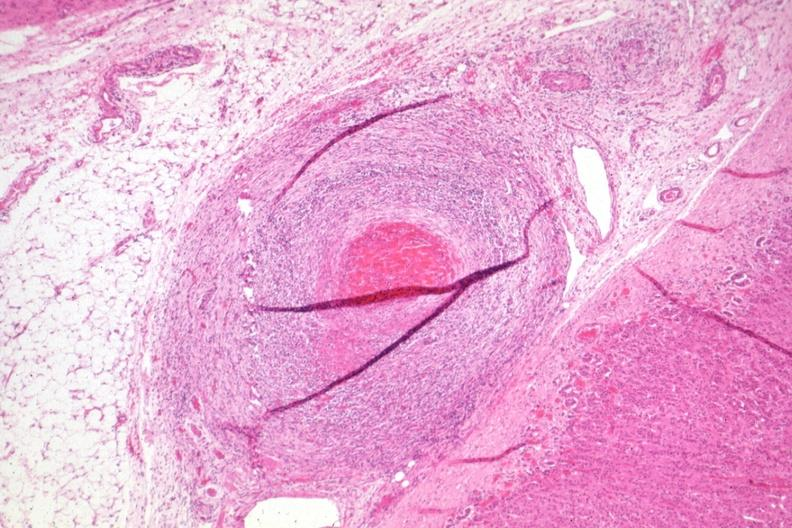has cachexia folds?
Answer the question using a single word or phrase. No 